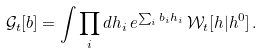<formula> <loc_0><loc_0><loc_500><loc_500>\mathcal { G } _ { t } [ b ] = \int \prod _ { i } d h _ { i } \, e ^ { \sum _ { i } b _ { i } h _ { i } } \, \mathcal { W } _ { t } [ h | h ^ { 0 } ] \, .</formula> 